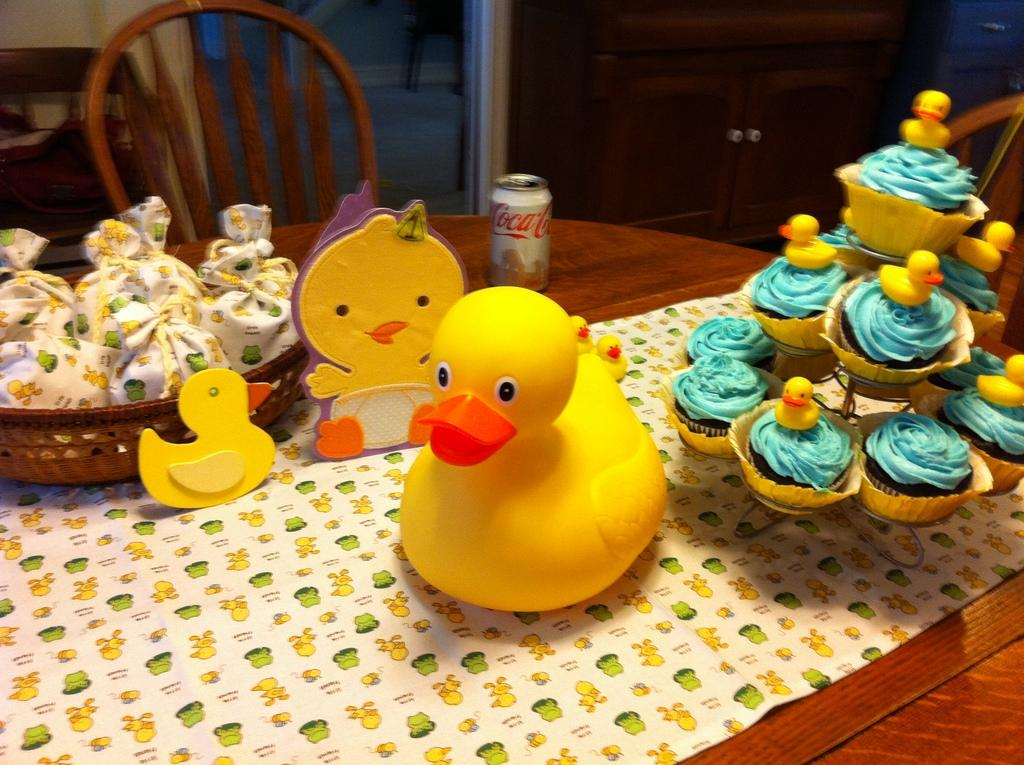What type of furniture is present in the image? There is a table in the image. Are there any seating options near the table? Yes, there are chairs in the image. What type of food items can be seen on the table? There are cupcakes on the table. What else is present on the table besides food items? There are toys on the table. What is the can in the image used for? The purpose of the can in the image is not specified, but it could be used for holding various items. Where is the lettuce being stored in the image? There is no lettuce present in the image. What type of calendar is visible on the table? There is no calendar present in the image. 